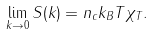<formula> <loc_0><loc_0><loc_500><loc_500>\lim _ { k \to 0 } S ( k ) = n _ { c } k _ { B } T \chi _ { T } .</formula> 